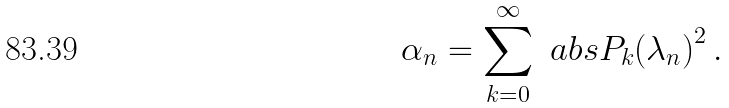Convert formula to latex. <formula><loc_0><loc_0><loc_500><loc_500>\alpha _ { n } = \sum _ { k = 0 } ^ { \infty } \ a b s { P _ { k } ( \lambda _ { n } ) } ^ { 2 } \, .</formula> 